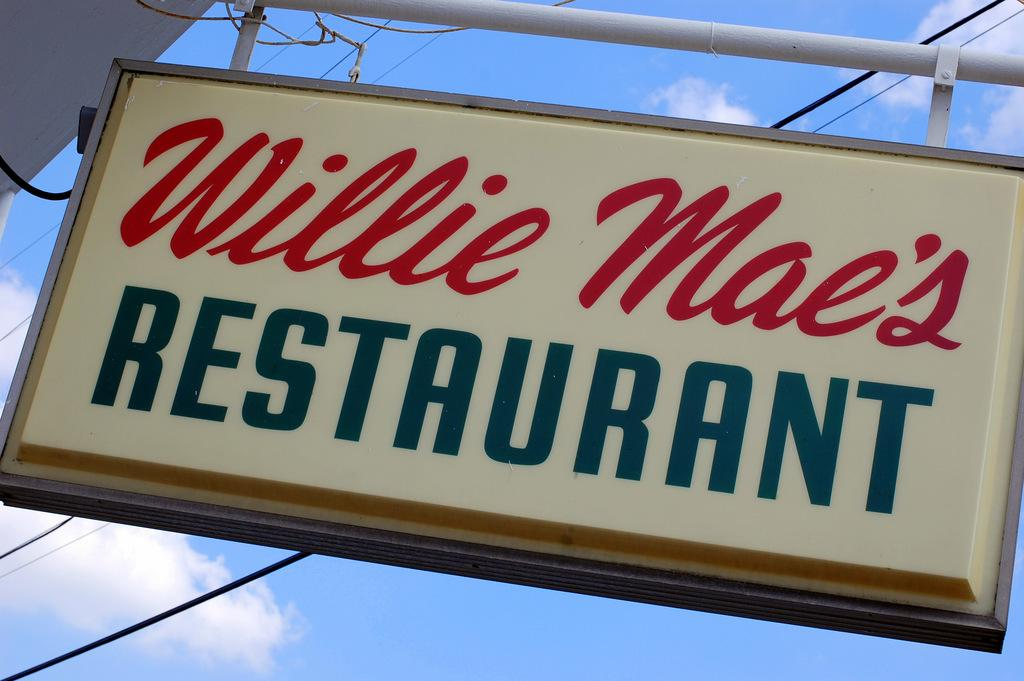<image>
Give a short and clear explanation of the subsequent image. A sign is hanging for Willie Mac's Restaurant.. 